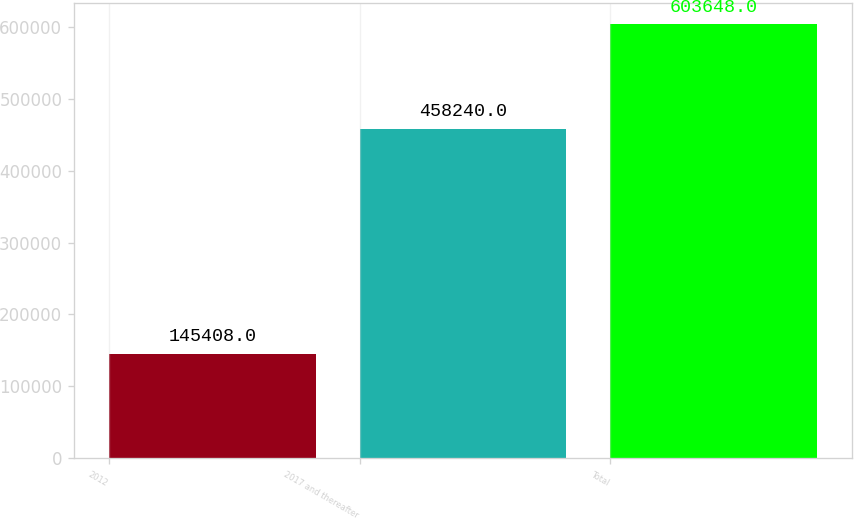<chart> <loc_0><loc_0><loc_500><loc_500><bar_chart><fcel>2012<fcel>2017 and thereafter<fcel>Total<nl><fcel>145408<fcel>458240<fcel>603648<nl></chart> 